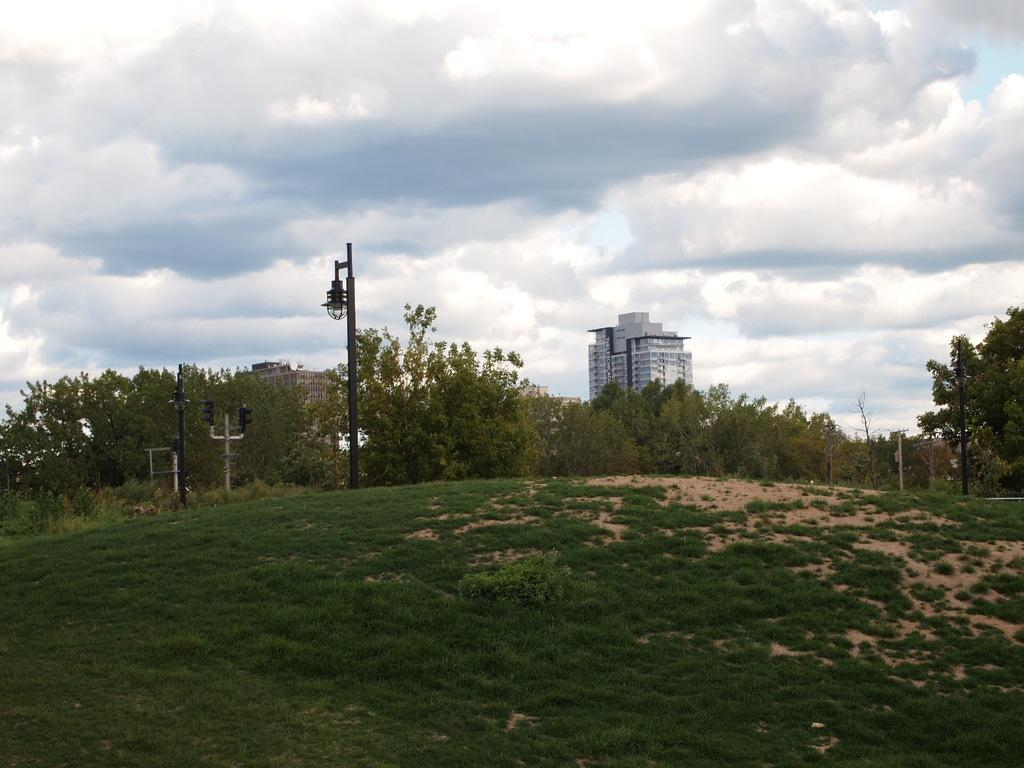What type of vegetation can be seen in the image? There are trees in the image. What structures are present in the image? There are poles, lights, and buildings in the image. What type of ground surface is visible in the image? There is grass in the image. What can be seen in the background of the image? The sky with clouds is visible in the background of the image. How many brothers are playing with the sheep in the image? There are no brothers or sheep present in the image. What type of gate can be seen in the image? There is no gate present in the image. 